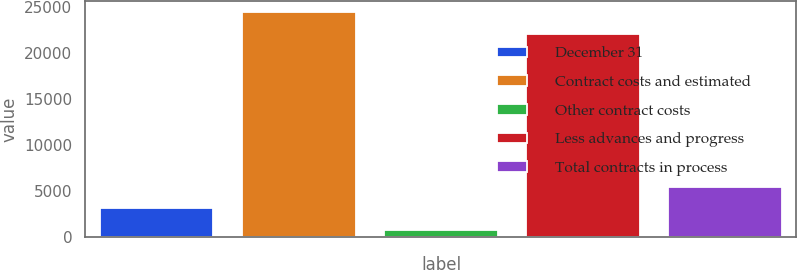Convert chart to OTSL. <chart><loc_0><loc_0><loc_500><loc_500><bar_chart><fcel>December 31<fcel>Contract costs and estimated<fcel>Other contract costs<fcel>Less advances and progress<fcel>Total contracts in process<nl><fcel>3170.6<fcel>24465.6<fcel>815<fcel>22110<fcel>5526.2<nl></chart> 